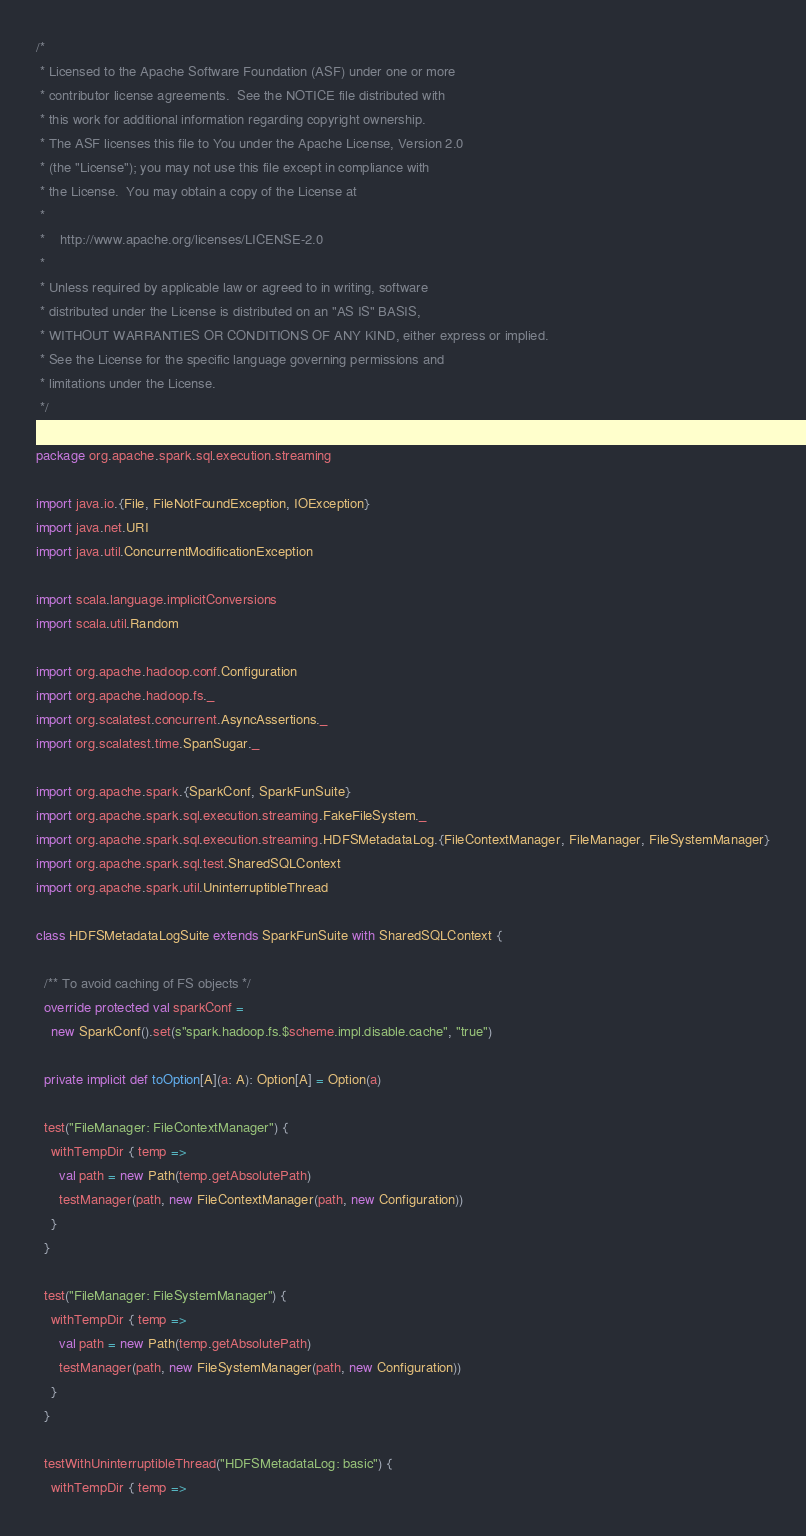<code> <loc_0><loc_0><loc_500><loc_500><_Scala_>/*
 * Licensed to the Apache Software Foundation (ASF) under one or more
 * contributor license agreements.  See the NOTICE file distributed with
 * this work for additional information regarding copyright ownership.
 * The ASF licenses this file to You under the Apache License, Version 2.0
 * (the "License"); you may not use this file except in compliance with
 * the License.  You may obtain a copy of the License at
 *
 *    http://www.apache.org/licenses/LICENSE-2.0
 *
 * Unless required by applicable law or agreed to in writing, software
 * distributed under the License is distributed on an "AS IS" BASIS,
 * WITHOUT WARRANTIES OR CONDITIONS OF ANY KIND, either express or implied.
 * See the License for the specific language governing permissions and
 * limitations under the License.
 */

package org.apache.spark.sql.execution.streaming

import java.io.{File, FileNotFoundException, IOException}
import java.net.URI
import java.util.ConcurrentModificationException

import scala.language.implicitConversions
import scala.util.Random

import org.apache.hadoop.conf.Configuration
import org.apache.hadoop.fs._
import org.scalatest.concurrent.AsyncAssertions._
import org.scalatest.time.SpanSugar._

import org.apache.spark.{SparkConf, SparkFunSuite}
import org.apache.spark.sql.execution.streaming.FakeFileSystem._
import org.apache.spark.sql.execution.streaming.HDFSMetadataLog.{FileContextManager, FileManager, FileSystemManager}
import org.apache.spark.sql.test.SharedSQLContext
import org.apache.spark.util.UninterruptibleThread

class HDFSMetadataLogSuite extends SparkFunSuite with SharedSQLContext {

  /** To avoid caching of FS objects */
  override protected val sparkConf =
    new SparkConf().set(s"spark.hadoop.fs.$scheme.impl.disable.cache", "true")

  private implicit def toOption[A](a: A): Option[A] = Option(a)

  test("FileManager: FileContextManager") {
    withTempDir { temp =>
      val path = new Path(temp.getAbsolutePath)
      testManager(path, new FileContextManager(path, new Configuration))
    }
  }

  test("FileManager: FileSystemManager") {
    withTempDir { temp =>
      val path = new Path(temp.getAbsolutePath)
      testManager(path, new FileSystemManager(path, new Configuration))
    }
  }

  testWithUninterruptibleThread("HDFSMetadataLog: basic") {
    withTempDir { temp =></code> 